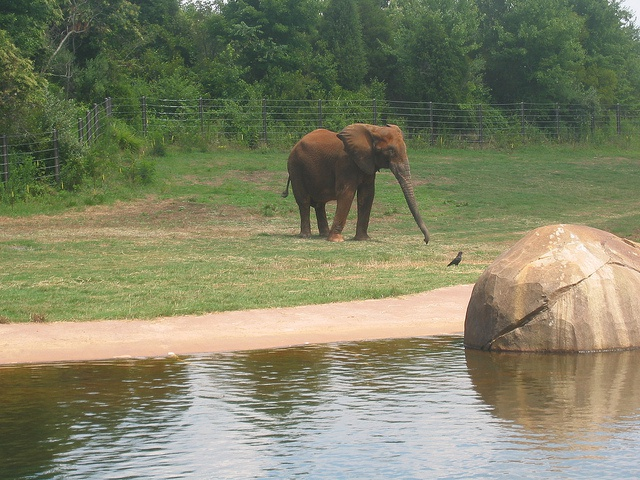Describe the objects in this image and their specific colors. I can see elephant in black and gray tones and bird in black, gray, and tan tones in this image. 